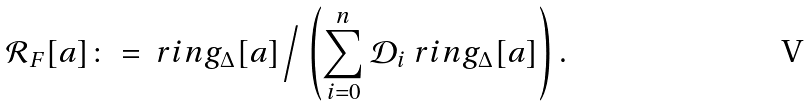Convert formula to latex. <formula><loc_0><loc_0><loc_500><loc_500>\mathcal { R } _ { F } [ a ] \colon = \ r i n g _ { \Delta } [ a ] \Big / \left ( \sum _ { i = 0 } ^ { n } \mathcal { D } _ { i } \ r i n g _ { \Delta } [ a ] \right ) .</formula> 